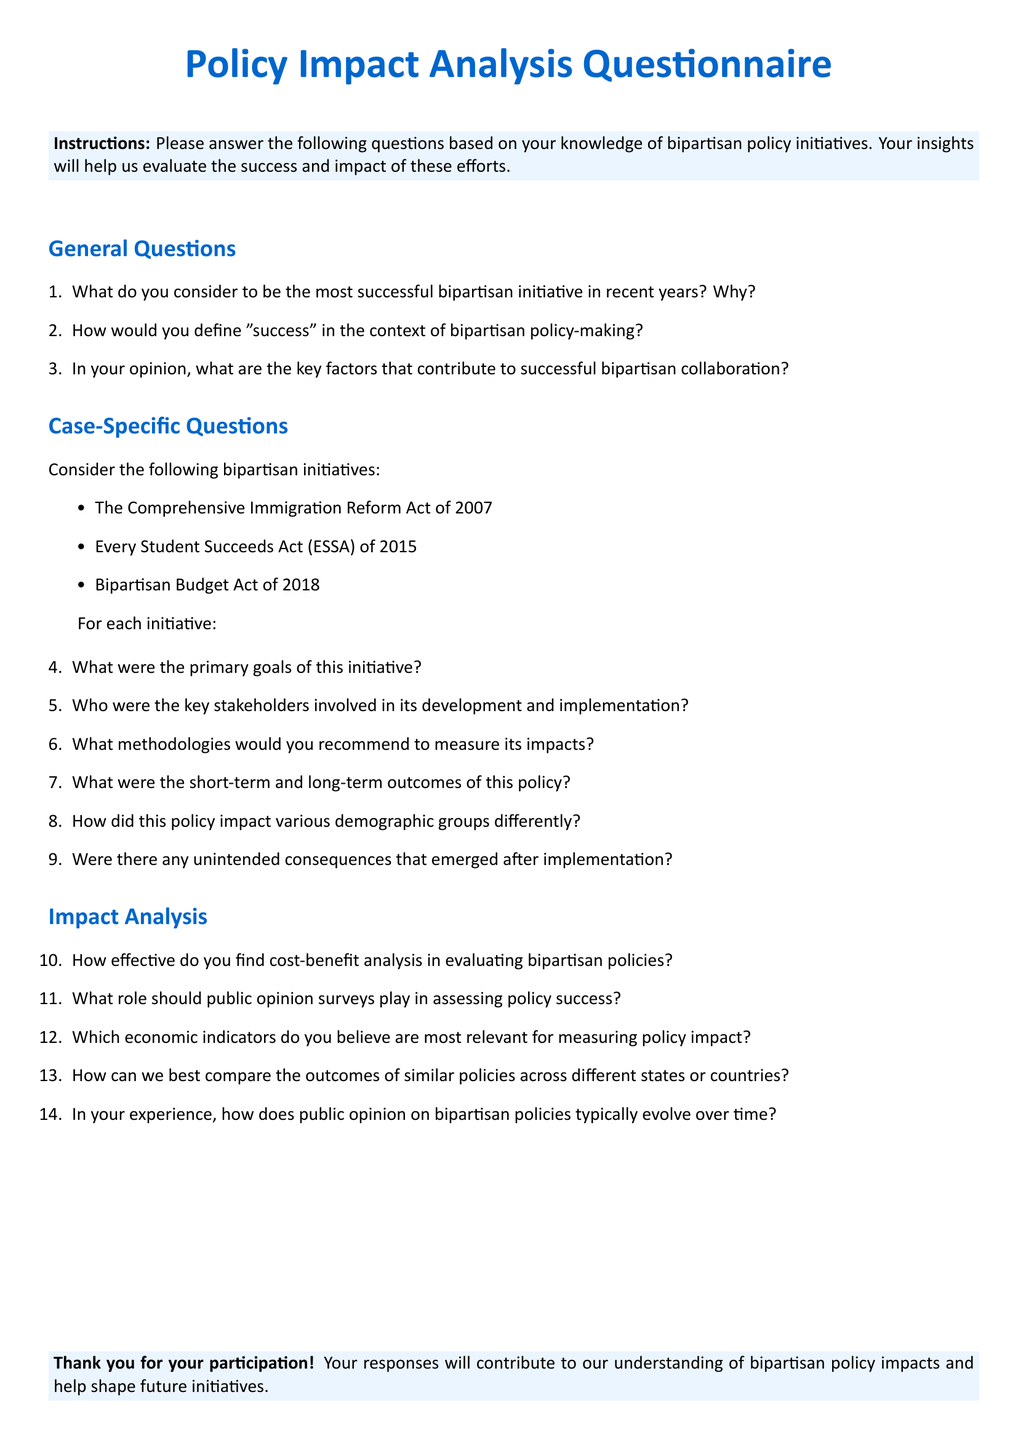What is the title of the document? The title appears at the center of the first page in a large font.
Answer: Policy Impact Analysis Questionnaire What are the three bipartisan initiatives listed in the document? These initiatives are specified in a bulleted list under the case-specific questions section.
Answer: Comprehensive Immigration Reform Act of 2007, Every Student Succeeds Act (ESSA) of 2015, Bipartisan Budget Act of 2018 What color is used for the section titles? The color specification is mentioned in the document setup for section formatting.
Answer: myblue How many general questions are included in the questionnaire? The total number of questions is counted in the general questions section.
Answer: Three What should participants provide at the end of the questionnaire? The closing instructions suggest what participants should do upon completing the questionnaire.
Answer: Responses Which economic indicators are relevant for measuring policy impact? This is asked in a specific section of the questionnaire regarding impact analysis.
Answer: Not specified (open-ended) What is the purpose of public opinion surveys in policy assessment? This question is posed in the impact analysis section, aiming to assess the role of public surveys.
Answer: Not specified (open-ended) What is the background color of the instruction box? The instruction box has a specific color defined in the document.
Answer: mylightblue 